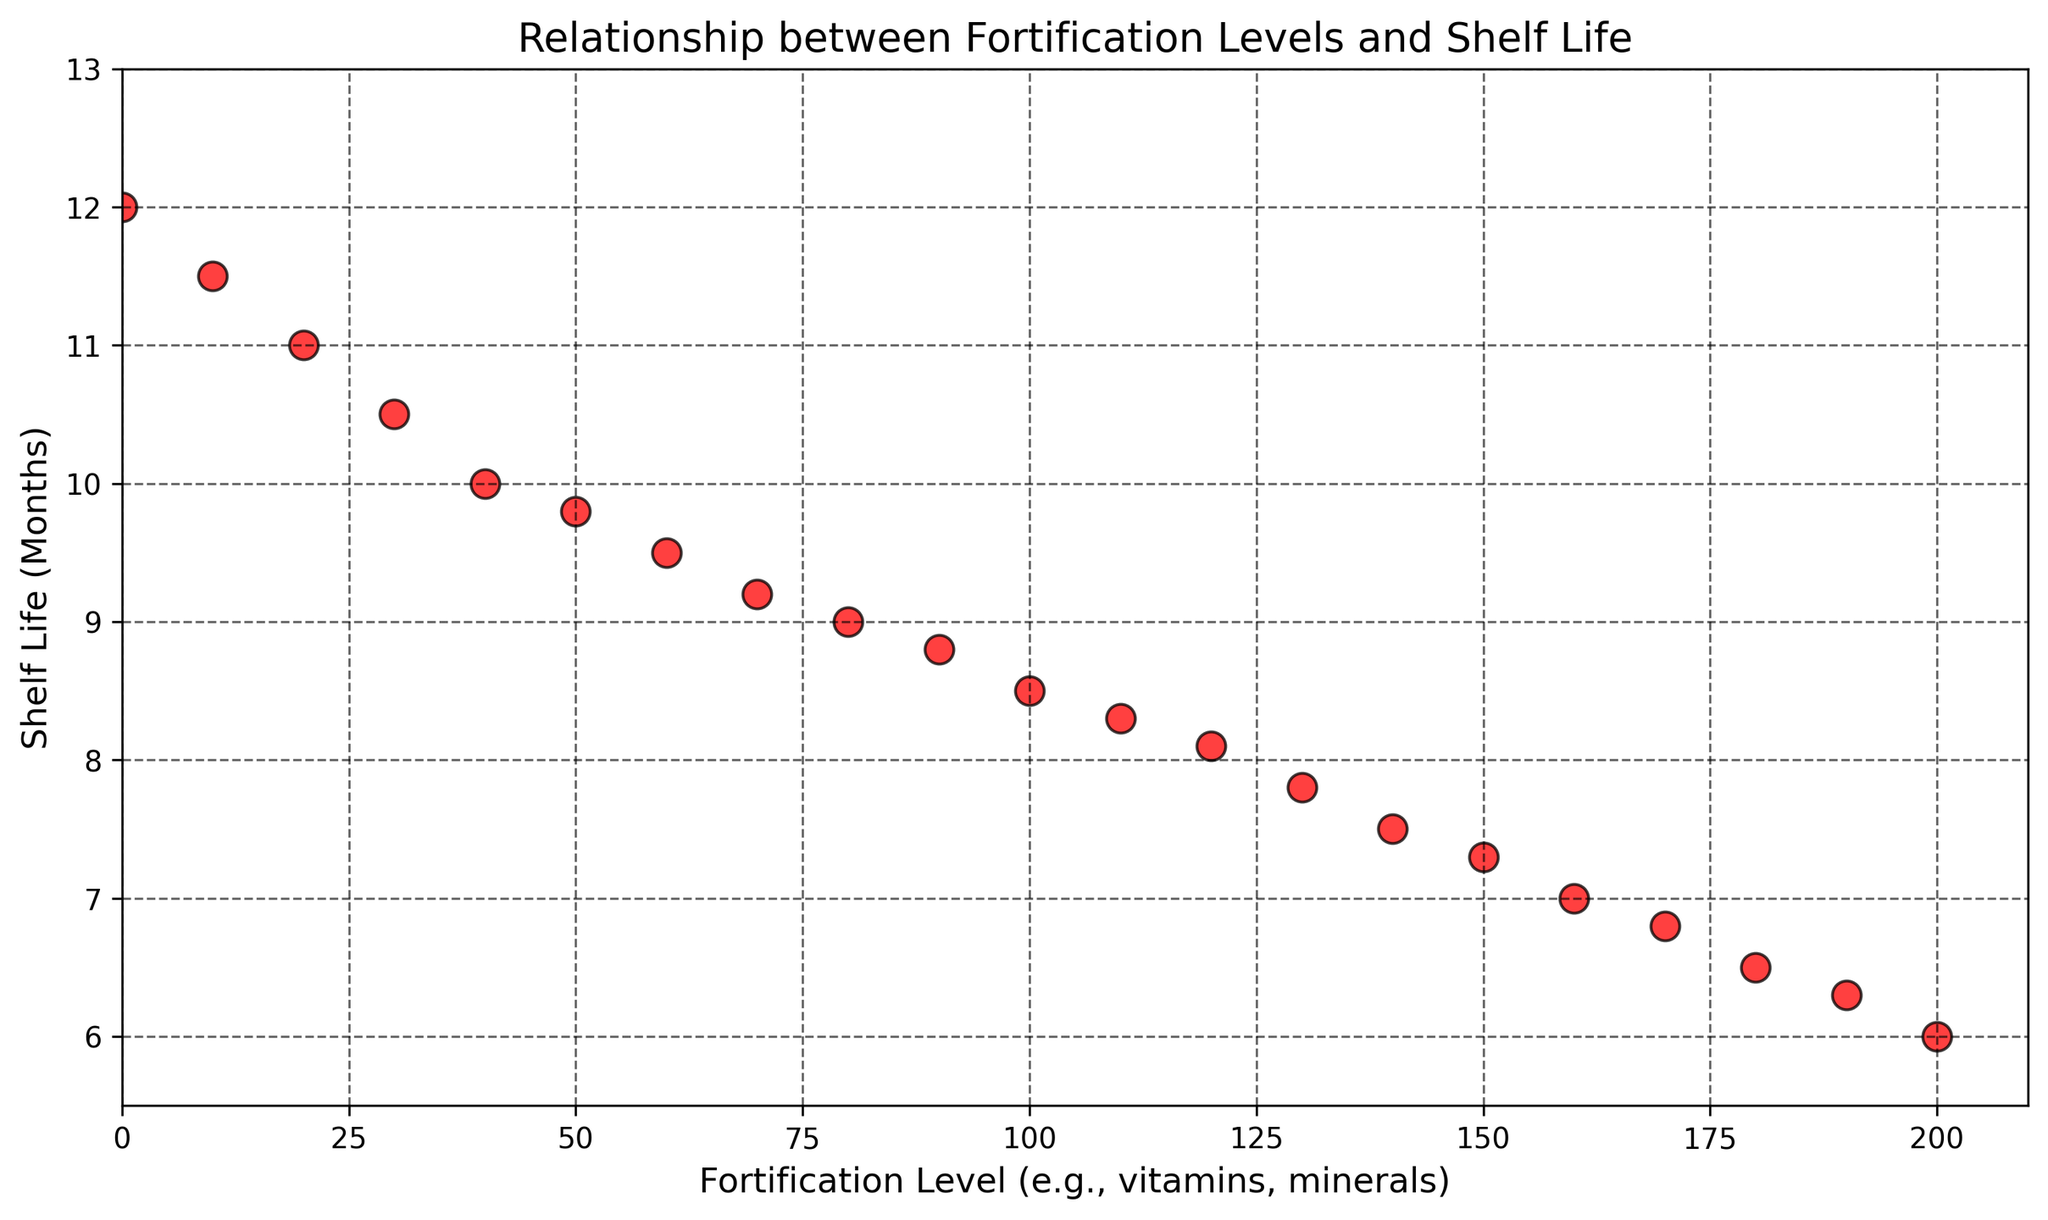What's the fortification level at the maximum shelf life? The scatter plot shows that the highest shelf life is 12 months. By looking at the data points, we can see that this occurs when the fortification level is at 0.
Answer: 0 What's the difference in shelf life between the fortification levels of 20 and 150? At a fortification level of 20, the shelf life is 11 months. At a fortification level of 150, the shelf life is 7.3 months. The difference is 11 - 7.3 = 3.7 months.
Answer: 3.7 months How does shelf life change as fortification levels increase across the first 100 units? Look at the trend of the data points from 0 fortification to 100 fortification. As the fortification levels increase to 100, the shelf life decreases from 12 months to 8.5 months.
Answer: It decreases Compare the shelf life at a fortification level of 80 to the shelf life at a fortification level of 180. Which is greater? At a fortification level of 80, the shelf life is 9 months. At a fortification level of 180, the shelf life is 6.5 months. 9 months is greater than 6.5 months.
Answer: Fortification level of 80 What’s the average shelf life across the entire range of fortification levels shown? To find the average shelf life, sum all the shelf life values and divide by the number of data points. Sum = 12 + 11.5 + 11 + 10.5 + 10 + 9.8 + 9.5 + 9.2 + 9 + 8.8 + 8.5 + 8.3 + 8.1 + 7.8 + 7.5 + 7.3 + 7 + 6.8 + 6.5 + 6.3 + 6 = 189, number of points = 21. Average = 189 / 21 = 9 months.
Answer: 9 months Is the trend of the relationship between fortification levels and shelf life positive, negative, or neutral? Observing the scatter plot, as fortification levels increase, the shelf life consistently decreases, which indicates a negative trend.
Answer: Negative What's the visual relationship between the data point colors and their respective values? All data points are the same color (red) in the scatter plot, indicating that color is not used to differentiate values, only position on the graph.
Answer: No relationship Which fortification level shows the sharpest decline in shelf life? Between fortification levels of 10 and 20, the shelf life goes from 11.5 to 11, a 0.5 month drop. The sharpest single drop in shelf life, though, is between 0 and 10, which shows a decline from 12 to 11.5, a 0.5 month drop as well.
Answer: Fortification level of 0 to 10 What is the shelf life at the median fortification level? The fortification levels range from 0 to 200. The median fortification level is the middle value, which is 100 units. The shelf life at 100 units is 8.5 months.
Answer: 8.5 months Is there any fortification level that results in a shelf life below 6 months? Observing the scatter plot, the lowest recorded shelf life is at a fortification level of 200, which has a shelf life of 6 months. No fortification level shows a shelf life below 6 months.
Answer: No 